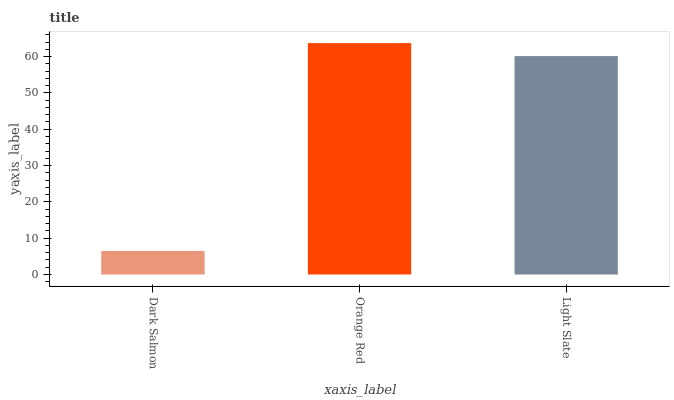Is Dark Salmon the minimum?
Answer yes or no. Yes. Is Orange Red the maximum?
Answer yes or no. Yes. Is Light Slate the minimum?
Answer yes or no. No. Is Light Slate the maximum?
Answer yes or no. No. Is Orange Red greater than Light Slate?
Answer yes or no. Yes. Is Light Slate less than Orange Red?
Answer yes or no. Yes. Is Light Slate greater than Orange Red?
Answer yes or no. No. Is Orange Red less than Light Slate?
Answer yes or no. No. Is Light Slate the high median?
Answer yes or no. Yes. Is Light Slate the low median?
Answer yes or no. Yes. Is Orange Red the high median?
Answer yes or no. No. Is Orange Red the low median?
Answer yes or no. No. 